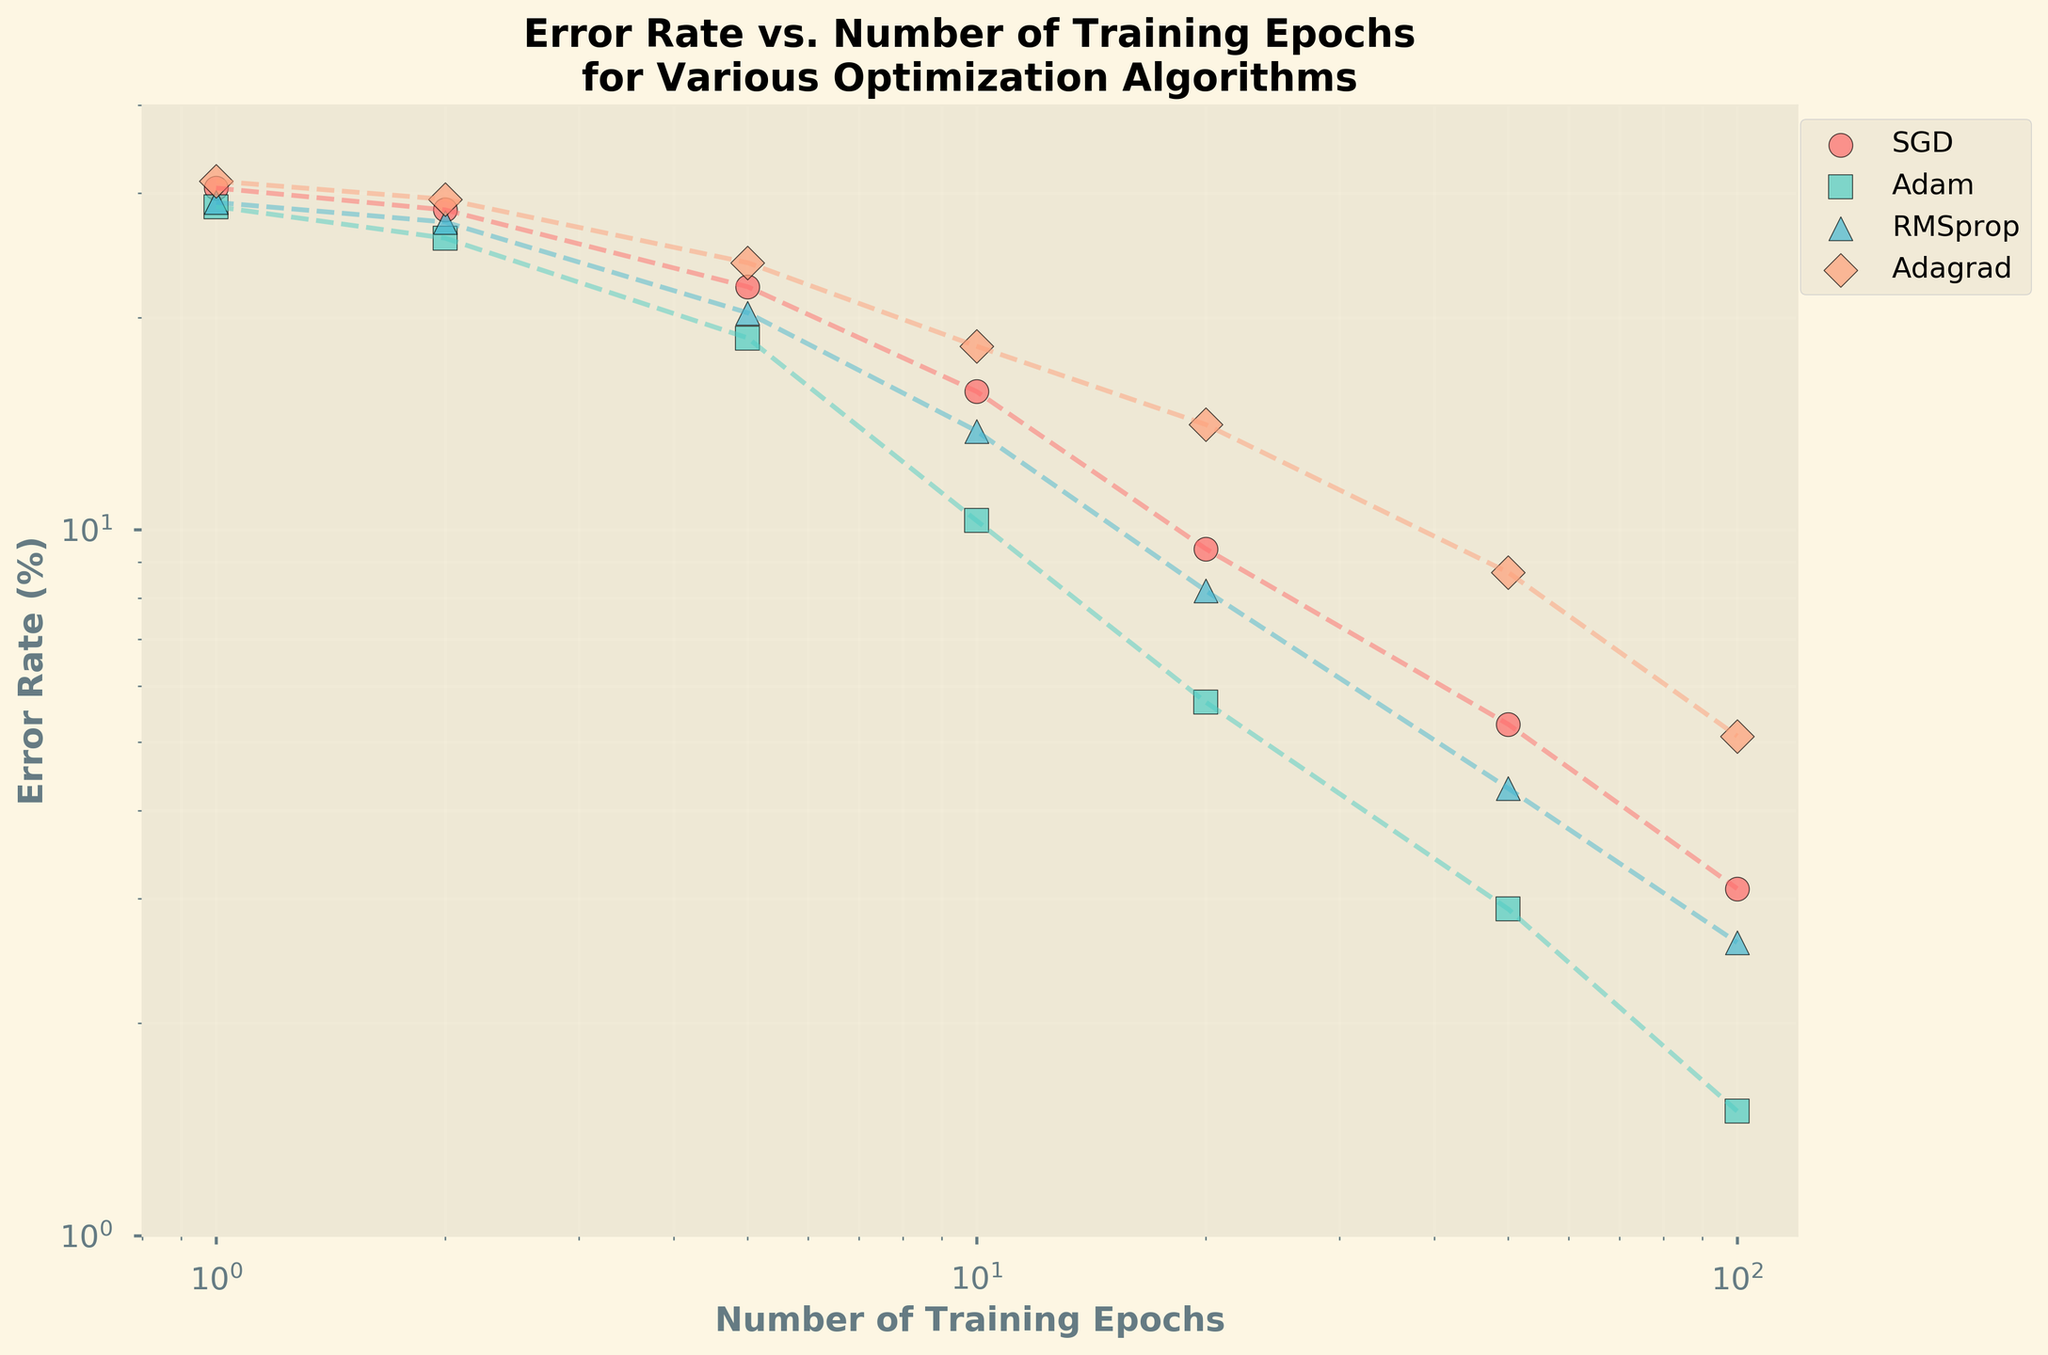What is the title of the figure? The title is located at the top of the figure. It reads "Error Rate vs. Number of Training Epochs for Various Optimization Algorithms".
Answer: Error Rate vs. Number of Training Epochs for Various Optimization Algorithms How many optimization algorithms are shown in the plot? The plot legend lists the different optimization algorithms. There are four algorithms named: SGD, Adam, RMSprop, and Adagrad.
Answer: 4 Which algorithm has the lowest error rate at 100 epochs? Locate the 100 epochs mark on the x-axis and find the corresponding error rates for each algorithm on the y-axis. Adam shows the lowest error rate at this point.
Answer: Adam At 20 epochs, which algorithm shows the highest error rate? At 20 epochs, trace vertically to the y-axis values for each algorithm. Adagrad has the highest error rate at this epoch.
Answer: Adagrad What is the error rate for RMSprop at 50 epochs? Find 50 epochs on the x-axis and trace vertically to the RMSprop line. The y-axis value at this point represents the error rate, which is 4.3%.
Answer: 4.3% Between which epochs does SGD show the largest decrease in error rate? Compare the error rate drop between consecutive epoch intervals. SGD shows the most significant decrease between 10 epochs (15.7%) and 20 epochs (9.4%).
Answer: Between 10 and 20 epochs By how much does the error rate of Adam decrease from 1 epoch to 10 epochs? With Adam, the error rate decreases from 28.7% at 1 epoch to 10.3% at 10 epochs. Subtract the two values (28.7 - 10.3 = 18.4).
Answer: 18.4% Among the given algorithms, which one generally shows the steepest decline in error rate? Observe the slopes of the error rate lines for each algorithm. Adam's line shows the steepest decline.
Answer: Adam What is the overall trend of error rates as the number of training epochs increases? The overall trend for all algorithms is a downward trend in error rates as the number of epochs increases.
Answer: Downward trend How does the error rate change for Adagrad from 1 epoch to 100 epochs? Trace Adagrad's error rates from 1 epoch (31.2%) to 100 epochs (5.1%). It shows a significant decrease.
Answer: Significant decrease 